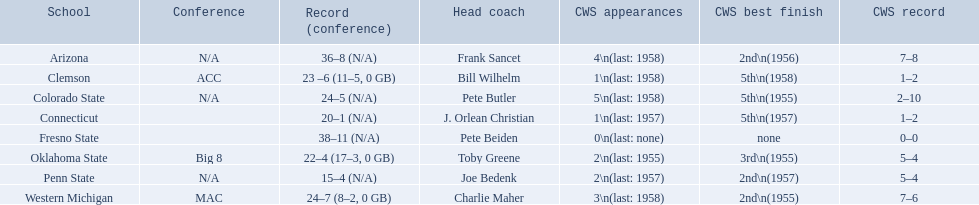Would you mind parsing the complete table? {'header': ['School', 'Conference', 'Record (conference)', 'Head coach', 'CWS appearances', 'CWS best finish', 'CWS record'], 'rows': [['Arizona', 'N/A', '36–8 (N/A)', 'Frank Sancet', '4\\n(last: 1958)', '2nd\\n(1956)', '7–8'], ['Clemson', 'ACC', '23 –6 (11–5, 0 GB)', 'Bill Wilhelm', '1\\n(last: 1958)', '5th\\n(1958)', '1–2'], ['Colorado State', 'N/A', '24–5 (N/A)', 'Pete Butler', '5\\n(last: 1958)', '5th\\n(1955)', '2–10'], ['Connecticut', '', '20–1 (N/A)', 'J. Orlean Christian', '1\\n(last: 1957)', '5th\\n(1957)', '1–2'], ['Fresno State', '', '38–11 (N/A)', 'Pete Beiden', '0\\n(last: none)', 'none', '0–0'], ['Oklahoma State', 'Big 8', '22–4 (17–3, 0 GB)', 'Toby Greene', '2\\n(last: 1955)', '3rd\\n(1955)', '5–4'], ['Penn State', 'N/A', '15–4 (N/A)', 'Joe Bedenk', '2\\n(last: 1957)', '2nd\\n(1957)', '5–4'], ['Western Michigan', 'MAC', '24–7 (8–2, 0 GB)', 'Charlie Maher', '3\\n(last: 1958)', '2nd\\n(1955)', '7–6']]} Enumerate all the educational institutions? Arizona, Clemson, Colorado State, Connecticut, Fresno State, Oklahoma State, Penn State, Western Michigan. Which team managed to get 19 wins or less? Penn State. 